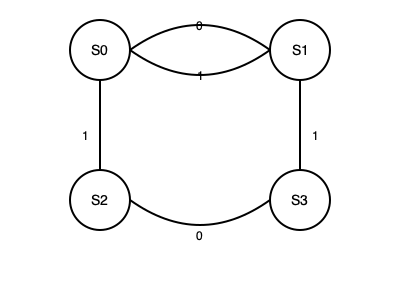Analyze the given state machine diagram and determine the sequence of inputs required to transition from state S0 to state S3. What is the minimum number of inputs needed? To find the minimum number of inputs needed to transition from state S0 to state S3, we need to analyze the state machine diagram step by step:

1. Start at state S0.
2. From S0, we have two possible transitions:
   a. Input 0 leads to S1
   b. Input 1 leads to S2
3. If we go to S1 (using input 0):
   a. From S1, input 1 is the only option, leading back to S0
   b. This creates a loop, not progressing towards S3
4. If we go to S2 (using input 1):
   a. From S2, input 0 is the only option, leading to S3
5. We have reached S3 in two steps: S0 → S2 → S3

Therefore, the minimum sequence of inputs to transition from S0 to S3 is:
1. Input 1 (S0 to S2)
2. Input 0 (S2 to S3)

The minimum number of inputs needed is 2.
Answer: 2 